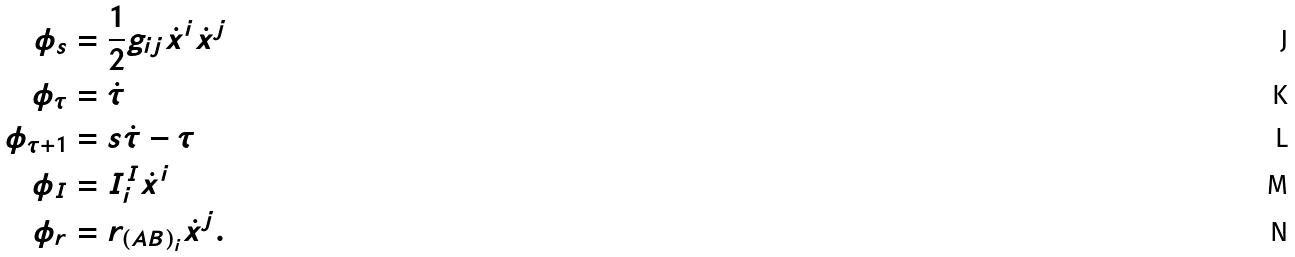<formula> <loc_0><loc_0><loc_500><loc_500>\phi _ { s } & = \frac { 1 } { 2 } g _ { i j } \dot { x } ^ { i } \dot { x } ^ { j } \\ \phi _ { \tau } & = \dot { \tau } \\ \phi _ { \tau + 1 } & = s \dot { \tau } - \tau \\ \phi _ { I } & = I _ { i } ^ { I } \dot { x } ^ { i } \\ \phi _ { r } & = r _ { \left ( A B \right ) _ { i } } \dot { x } ^ { j } .</formula> 